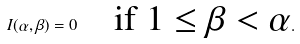<formula> <loc_0><loc_0><loc_500><loc_500>I ( \alpha , \beta ) = 0 \quad \text {if $1\leq\beta <\alpha$} .</formula> 